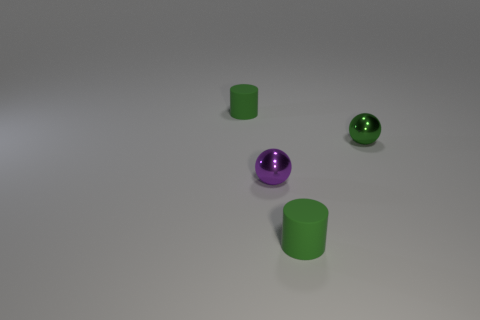Are the tiny green sphere and the sphere that is in front of the green metal ball made of the same material?
Ensure brevity in your answer.  Yes. Is the number of small balls greater than the number of green shiny things?
Provide a short and direct response. Yes. The metallic object that is in front of the green ball that is in front of the tiny rubber object left of the purple ball is what shape?
Provide a succinct answer. Sphere. Do the small purple sphere that is in front of the green metallic thing and the green sphere that is to the right of the small purple metal sphere have the same material?
Give a very brief answer. Yes. The green object that is the same material as the purple thing is what shape?
Ensure brevity in your answer.  Sphere. What number of purple metal objects are there?
Provide a short and direct response. 1. What is the tiny green cylinder that is to the right of the small green matte cylinder behind the green shiny thing made of?
Provide a succinct answer. Rubber. What is the color of the ball to the left of the green matte object on the right side of the small rubber cylinder that is to the left of the small purple shiny object?
Give a very brief answer. Purple. What number of other purple shiny balls are the same size as the purple shiny sphere?
Your response must be concise. 0. Are there more small purple metallic balls that are left of the purple object than tiny purple balls on the right side of the green sphere?
Keep it short and to the point. No. 